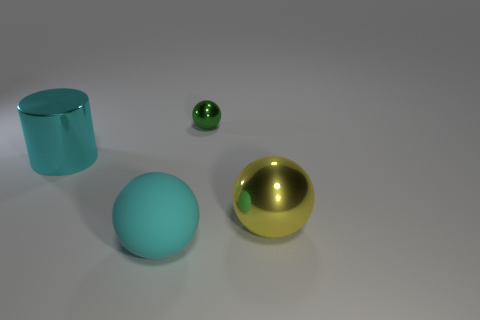Subtract all small green spheres. How many spheres are left? 2 Add 4 large objects. How many objects exist? 8 Subtract all balls. How many objects are left? 1 Subtract all small rubber cubes. Subtract all big cyan things. How many objects are left? 2 Add 3 tiny metallic spheres. How many tiny metallic spheres are left? 4 Add 4 big yellow shiny spheres. How many big yellow shiny spheres exist? 5 Subtract 0 red blocks. How many objects are left? 4 